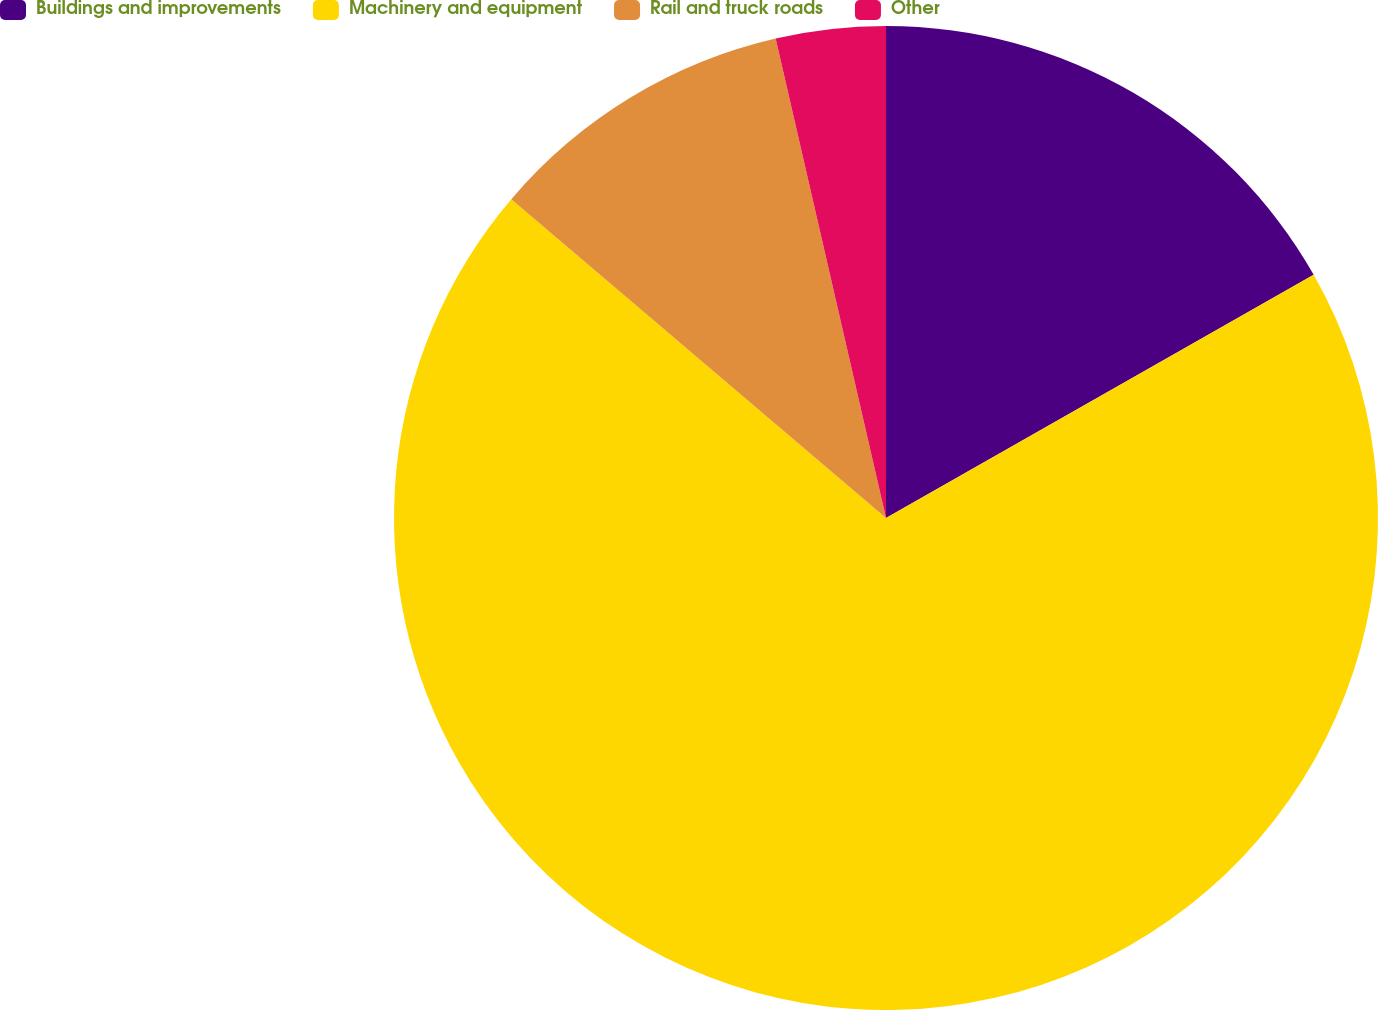Convert chart to OTSL. <chart><loc_0><loc_0><loc_500><loc_500><pie_chart><fcel>Buildings and improvements<fcel>Machinery and equipment<fcel>Rail and truck roads<fcel>Other<nl><fcel>16.77%<fcel>69.45%<fcel>10.18%<fcel>3.6%<nl></chart> 